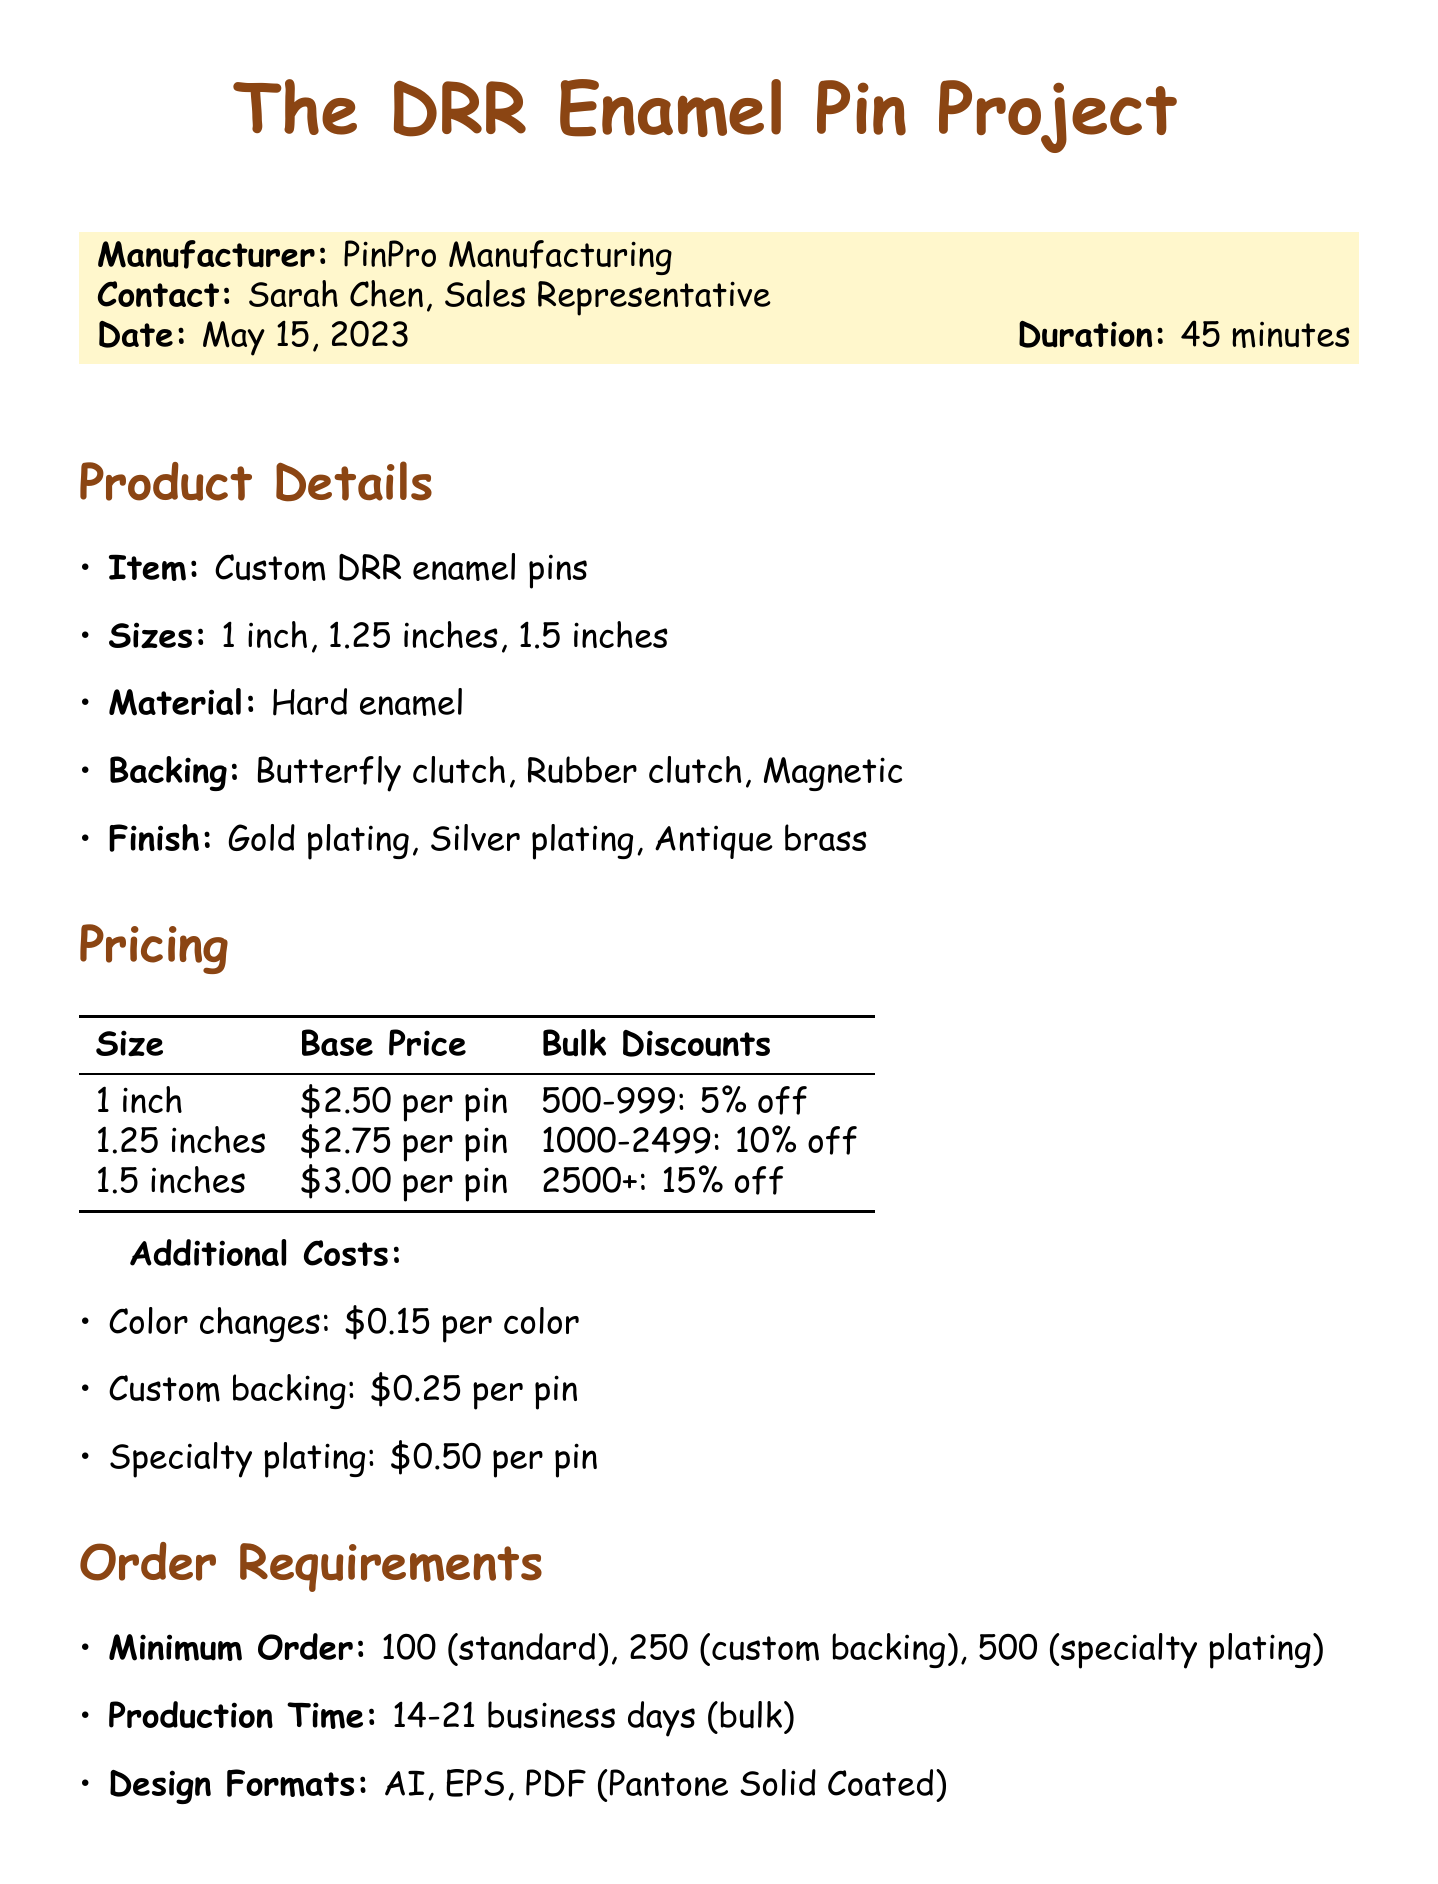What is the date of the call? The date of the call is mentioned in the document as May 15, 2023.
Answer: May 15, 2023 Who is the contact person at PinPro Manufacturing? The contact person's name is listed as Sarah Chen, who is the Sales Representative.
Answer: Sarah Chen What is the base price for a 1.25-inch pin? The base price for this size is explicitly stated in the pricing details.
Answer: $2.75 per pin What are the minimum order quantities for custom backing? The document specifies that the minimum order quantity for custom backing is 250.
Answer: 250 What is the additional cost for color changes? The document outlines the additional costs, specifically for color changes.
Answer: $0.15 per color How long is the production time for bulk orders? The production timeline section of the memo states the duration for bulk production.
Answer: 14-21 business days What is the payment term for the balance? The document specifies the payment term for the balance due before shipping.
Answer: 50% before shipping What options are available for pin backing? The document lists various backing options available for the pins.
Answer: Butterfly clutch, Rubber clutch, Magnetic What should be submitted within one week? The next steps section indicates what needs to be submitted within a week.
Answer: Finalized artwork 